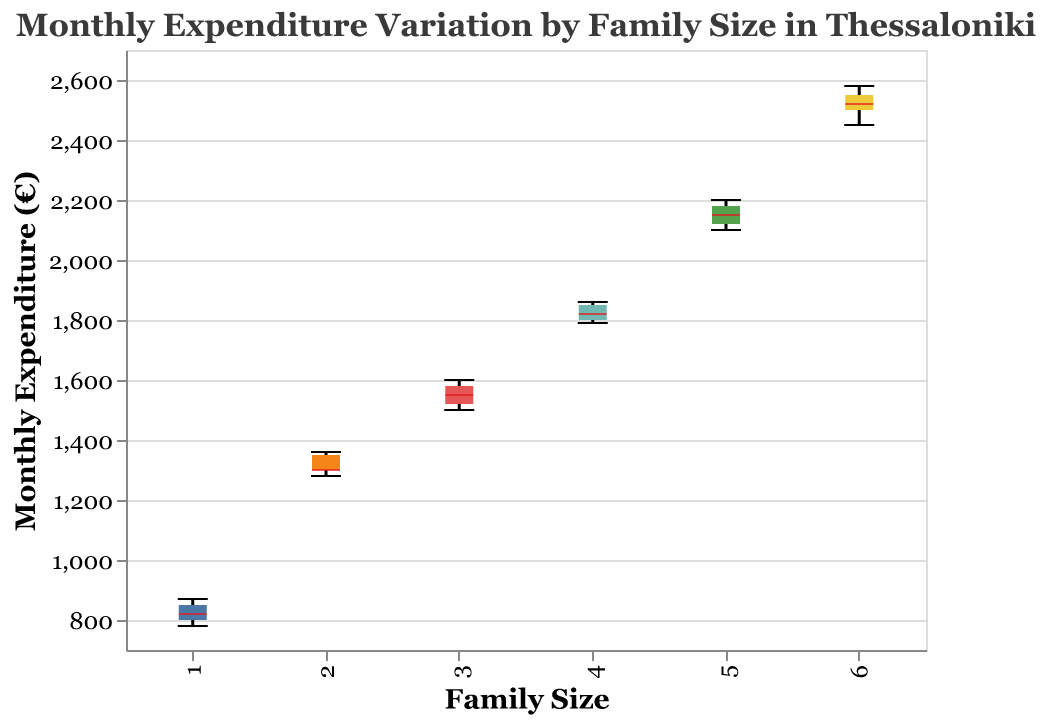What's the title of the plot? The title of the plot is located at the top and reads "Monthly Expenditure Variation by Family Size in Thessaloniki."
Answer: Monthly Expenditure Variation by Family Size in Thessaloniki What is the y-axis representing? The y-axis is labeled "Monthly Expenditure (€)" and it represents the monthly expenditure in euros for different family sizes.
Answer: Monthly Expenditure (€) What is the range of the y-axis? The y-axis ranges from 700 to 2700 euros, which can be observed from the minimum and maximum values on the y-axis scale.
Answer: 700 to 2700 Which family size has the widest interquartile range (IQR)? The widest interquartile range can be observed by looking at the width of the boxes in the plot. Family size 6 shows the widest IQR as its box is the widest among all groups.
Answer: Family size 6 For which family size is the median monthly expenditure the highest? The median can be identified by the white thick line inside each box. Family size 6 has the highest median monthly expenditure, which is around 2520 euros.
Answer: Family size 6 How does the median expenditure compare between family sizes 1 and 4? The median expenditure for family size 1 is around 820 euros, whereas for family size 4, it is around 1820 euros. Thus, the median expenditure for family size 4 is significantly higher than for family size 1.
Answer: Family size 4's median is higher Which family size shows the most variation in monthly expenditure? The most variation can be gauged by the extent of the boxplots and the length of the whiskers. Family size 6 shows the most variation as it has the longest whiskers stretching from around 2450 to 2580 euros.
Answer: Family size 6 Do any family sizes have overlapping notches, and what does it imply? Overlapping notches would indicate non-significant differences in medians. None of the family sizes have overlapping notches, implying their median expenditures are significantly different from each other.
Answer: No overlap, significant differences What are the mini and maximum monthly expenditures for family size 3? The minimum and maximum expenditures can be seen at the bottom and top of the whiskers for family size 3. They are approximately 1500 euros and 1600 euros respectively.
Answer: 1500 to 1600 euros Which family size has the smallest variation in monthly expenditure? To identify the smallest variation, we look for the smallest box and shortest whiskers. Family size 1 has the smallest variation as indicated by the tight box and short whiskers.
Answer: Family size 1 